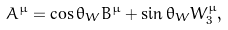Convert formula to latex. <formula><loc_0><loc_0><loc_500><loc_500>A ^ { \mu } = \cos { \theta _ { W } } B ^ { \mu } + \sin { \theta _ { W } } W _ { 3 } ^ { \mu } ,</formula> 